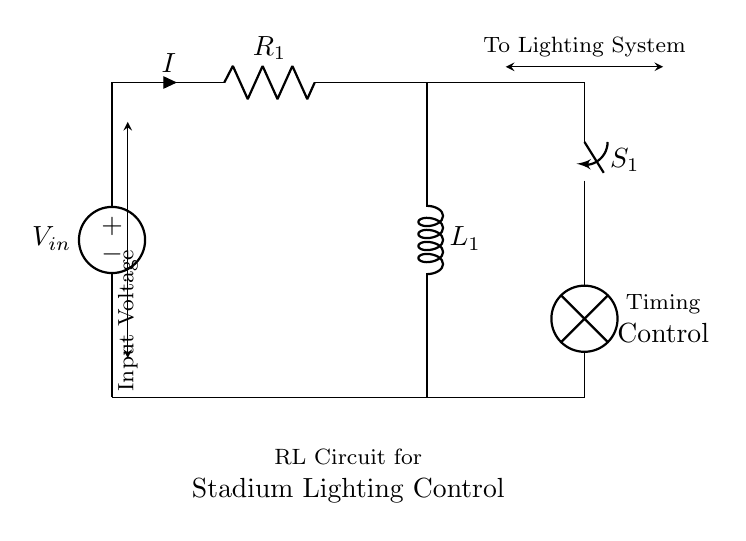what is the input voltage of the circuit? The input voltage is labeled as V in the circuit diagram.
Answer: V in what type of components are present in the circuit? The circuit consists of a voltage source, a resistor, an inductor, and a switch.
Answer: Voltage source, resistor, inductor, switch what is the function of the switch in the circuit? The switch allows for controlling the flow of current to the lighting system, effectively turning it on or off.
Answer: Control current flow how does the inductor influence current in the circuit? The inductor stores energy in a magnetic field when current flows through it, which affects how quickly the current can rise or fall, particularly influencing timing.
Answer: Stores energy what happens to the current when the switch is closed? When the switch is closed, the circuit is completed, allowing current to flow to the lamp, driven by the input voltage, potentially affecting the rate of current rise related to the inductor.
Answer: Current flows to lamp how would you calculate the time constant in this RL circuit? The time constant can be calculated using the formula Tau equals L over R, where L is the inductance of the coil and R is the resistance in ohms. This defines how quickly the circuit responds to changes.
Answer: L over R 